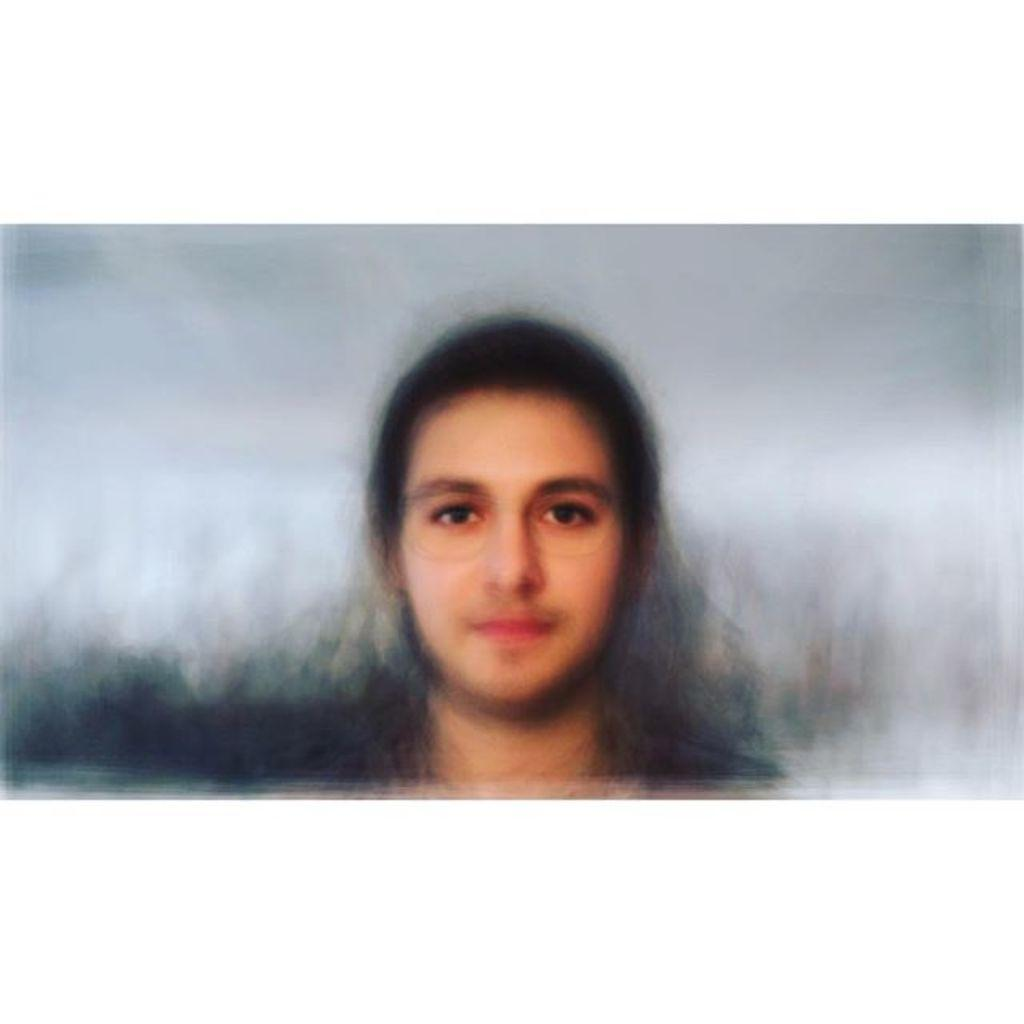What is the main subject of the image? There is a person in the image. Can you describe any characteristics of the image? The image appears to be edited, and the background of the image is blurred. How many mines can be seen in the image? There are no mines present in the image. What type of jump can be seen in the image? There is no jump present in the image. 